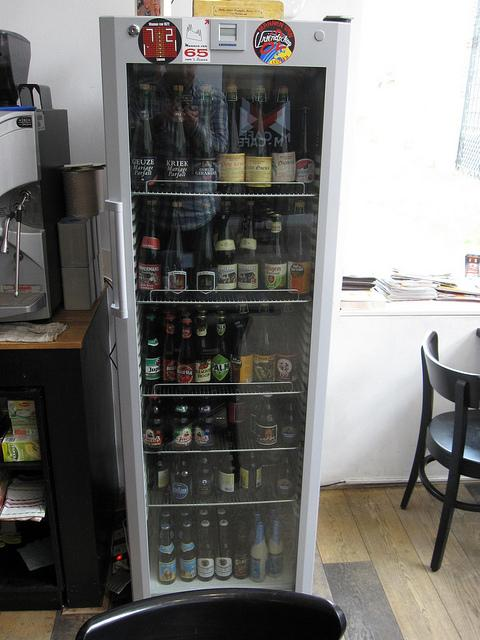What drink has the owner of this cooler stocked up on?

Choices:
A) beer
B) soda
C) water
D) wine water 